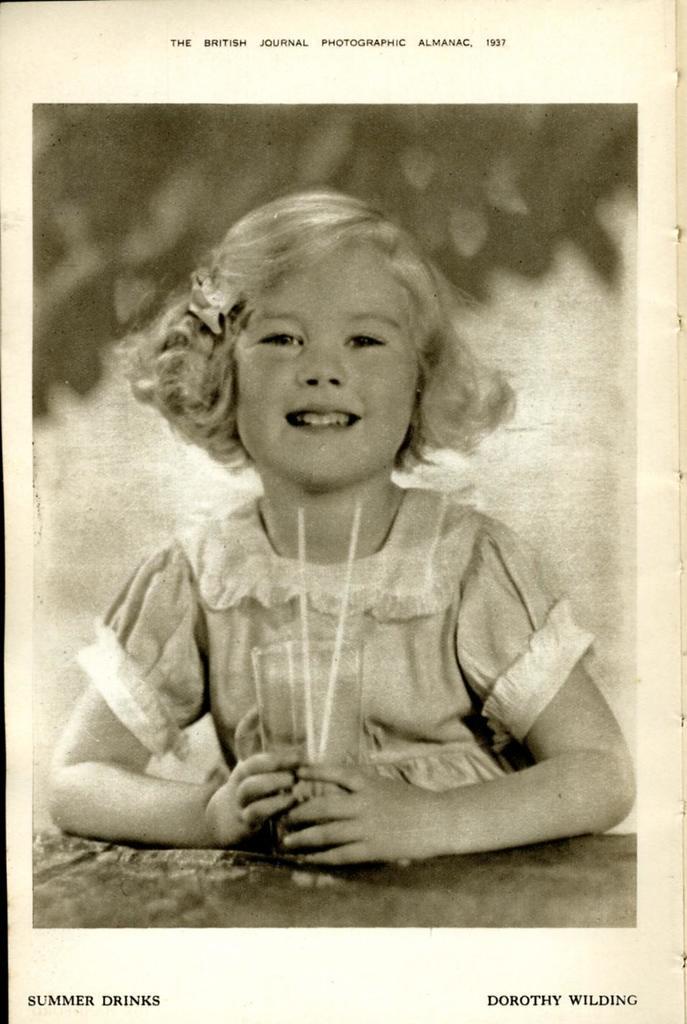In one or two sentences, can you explain what this image depicts? This is a black and white picture, in this image we can see a girl holding a glass, there are two straws in the glass, at the bottom and top of the image we can see some text. 